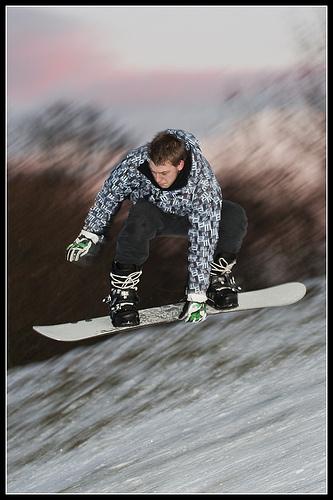Is this man wearing correct safety gear for this stunt?
Be succinct. No. Is this man wearing a hat?
Quick response, please. No. Does the man have gloves on his hands?
Short answer required. Yes. 